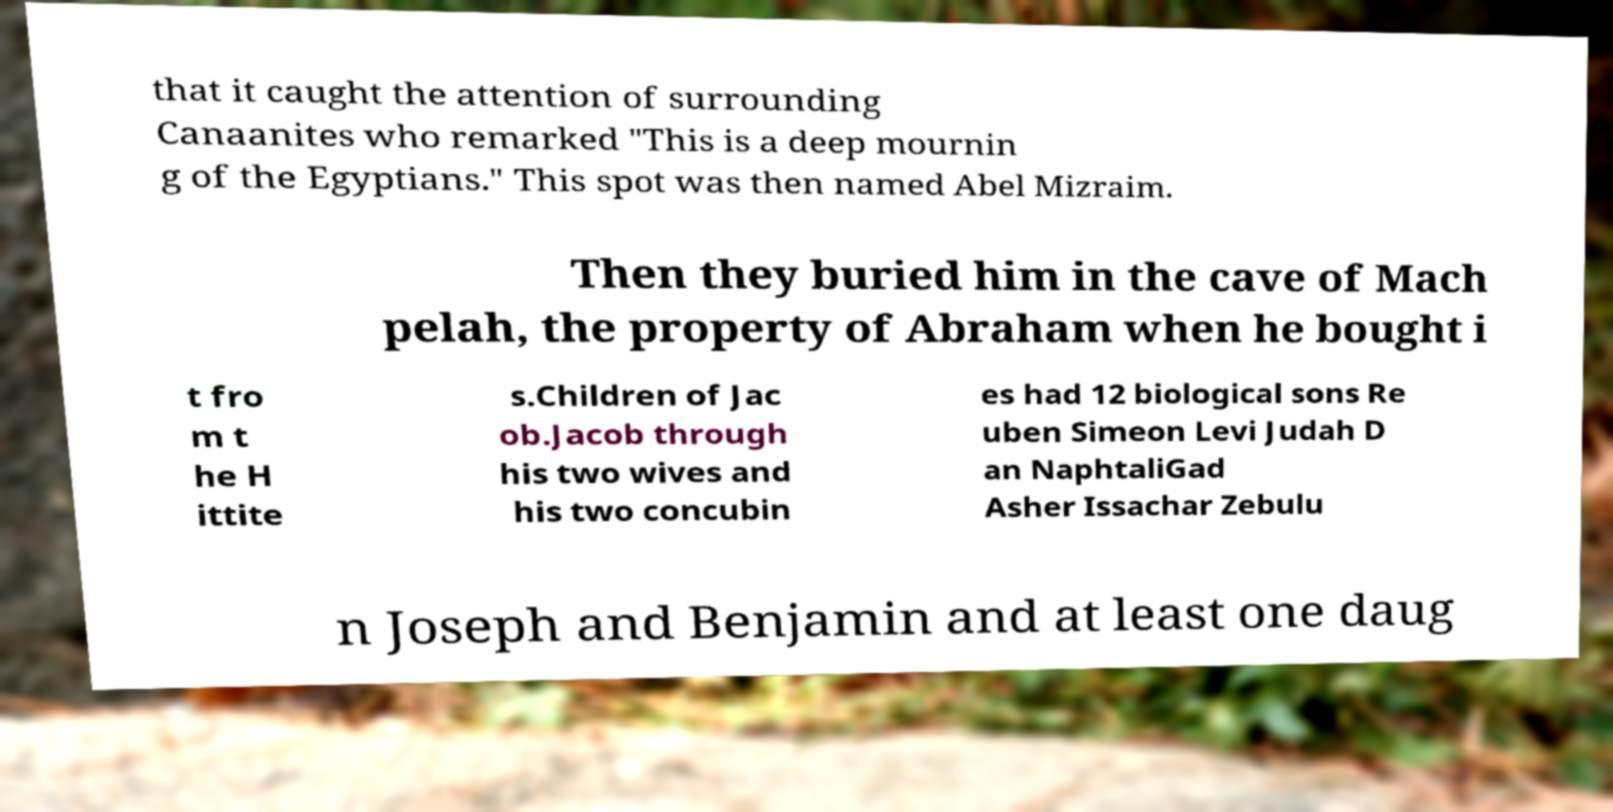I need the written content from this picture converted into text. Can you do that? that it caught the attention of surrounding Canaanites who remarked "This is a deep mournin g of the Egyptians." This spot was then named Abel Mizraim. Then they buried him in the cave of Mach pelah, the property of Abraham when he bought i t fro m t he H ittite s.Children of Jac ob.Jacob through his two wives and his two concubin es had 12 biological sons Re uben Simeon Levi Judah D an NaphtaliGad Asher Issachar Zebulu n Joseph and Benjamin and at least one daug 